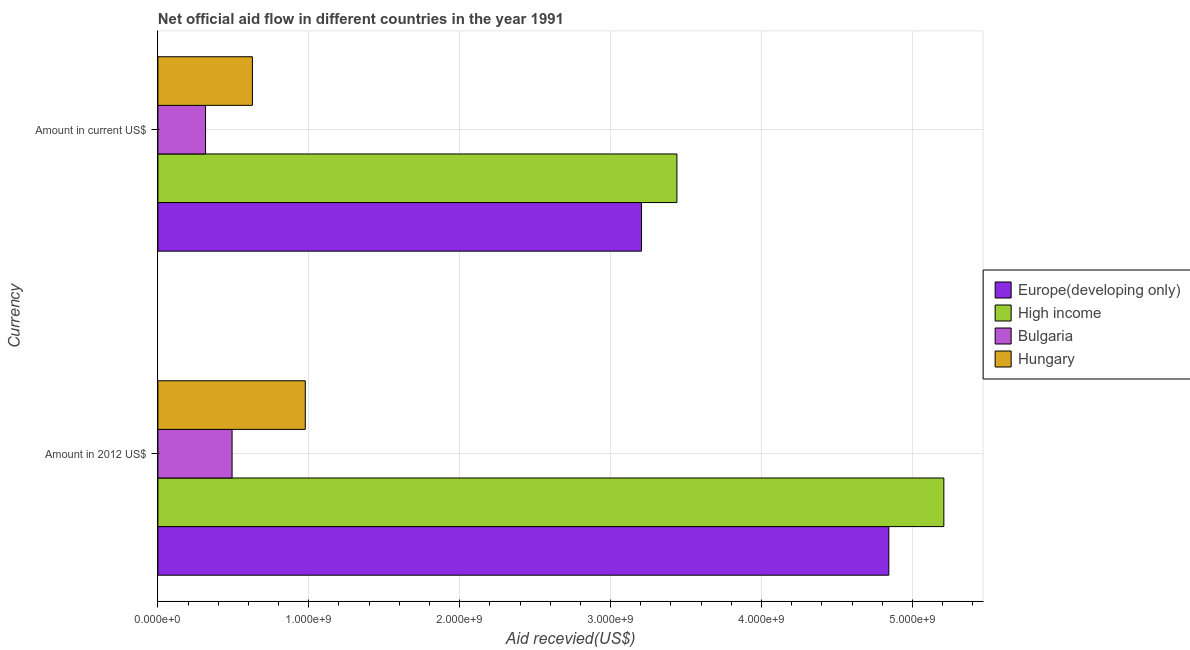Are the number of bars per tick equal to the number of legend labels?
Keep it short and to the point. Yes. Are the number of bars on each tick of the Y-axis equal?
Provide a short and direct response. Yes. How many bars are there on the 1st tick from the bottom?
Your response must be concise. 4. What is the label of the 1st group of bars from the top?
Make the answer very short. Amount in current US$. What is the amount of aid received(expressed in us$) in High income?
Give a very brief answer. 3.44e+09. Across all countries, what is the maximum amount of aid received(expressed in 2012 us$)?
Your response must be concise. 5.21e+09. Across all countries, what is the minimum amount of aid received(expressed in us$)?
Your answer should be very brief. 3.16e+08. In which country was the amount of aid received(expressed in us$) maximum?
Offer a terse response. High income. What is the total amount of aid received(expressed in us$) in the graph?
Provide a succinct answer. 7.59e+09. What is the difference between the amount of aid received(expressed in 2012 us$) in Bulgaria and that in High income?
Your answer should be very brief. -4.72e+09. What is the difference between the amount of aid received(expressed in us$) in Europe(developing only) and the amount of aid received(expressed in 2012 us$) in Bulgaria?
Make the answer very short. 2.71e+09. What is the average amount of aid received(expressed in us$) per country?
Make the answer very short. 1.90e+09. What is the difference between the amount of aid received(expressed in 2012 us$) and amount of aid received(expressed in us$) in Bulgaria?
Ensure brevity in your answer.  1.76e+08. In how many countries, is the amount of aid received(expressed in 2012 us$) greater than 2000000000 US$?
Your response must be concise. 2. What is the ratio of the amount of aid received(expressed in us$) in Hungary to that in Europe(developing only)?
Your answer should be compact. 0.2. Is the amount of aid received(expressed in 2012 us$) in Bulgaria less than that in Hungary?
Ensure brevity in your answer.  Yes. What does the 2nd bar from the top in Amount in 2012 US$ represents?
Ensure brevity in your answer.  Bulgaria. Are all the bars in the graph horizontal?
Provide a succinct answer. Yes. How are the legend labels stacked?
Provide a succinct answer. Vertical. What is the title of the graph?
Provide a short and direct response. Net official aid flow in different countries in the year 1991. What is the label or title of the X-axis?
Offer a terse response. Aid recevied(US$). What is the label or title of the Y-axis?
Your response must be concise. Currency. What is the Aid recevied(US$) in Europe(developing only) in Amount in 2012 US$?
Ensure brevity in your answer.  4.84e+09. What is the Aid recevied(US$) in High income in Amount in 2012 US$?
Your answer should be compact. 5.21e+09. What is the Aid recevied(US$) in Bulgaria in Amount in 2012 US$?
Give a very brief answer. 4.91e+08. What is the Aid recevied(US$) in Hungary in Amount in 2012 US$?
Your answer should be compact. 9.77e+08. What is the Aid recevied(US$) of Europe(developing only) in Amount in current US$?
Keep it short and to the point. 3.20e+09. What is the Aid recevied(US$) of High income in Amount in current US$?
Provide a succinct answer. 3.44e+09. What is the Aid recevied(US$) in Bulgaria in Amount in current US$?
Provide a short and direct response. 3.16e+08. What is the Aid recevied(US$) of Hungary in Amount in current US$?
Keep it short and to the point. 6.26e+08. Across all Currency, what is the maximum Aid recevied(US$) of Europe(developing only)?
Provide a short and direct response. 4.84e+09. Across all Currency, what is the maximum Aid recevied(US$) of High income?
Your answer should be very brief. 5.21e+09. Across all Currency, what is the maximum Aid recevied(US$) of Bulgaria?
Your answer should be compact. 4.91e+08. Across all Currency, what is the maximum Aid recevied(US$) of Hungary?
Offer a terse response. 9.77e+08. Across all Currency, what is the minimum Aid recevied(US$) in Europe(developing only)?
Offer a terse response. 3.20e+09. Across all Currency, what is the minimum Aid recevied(US$) of High income?
Your answer should be very brief. 3.44e+09. Across all Currency, what is the minimum Aid recevied(US$) of Bulgaria?
Ensure brevity in your answer.  3.16e+08. Across all Currency, what is the minimum Aid recevied(US$) in Hungary?
Your response must be concise. 6.26e+08. What is the total Aid recevied(US$) in Europe(developing only) in the graph?
Ensure brevity in your answer.  8.05e+09. What is the total Aid recevied(US$) of High income in the graph?
Ensure brevity in your answer.  8.65e+09. What is the total Aid recevied(US$) of Bulgaria in the graph?
Provide a succinct answer. 8.07e+08. What is the total Aid recevied(US$) in Hungary in the graph?
Give a very brief answer. 1.60e+09. What is the difference between the Aid recevied(US$) in Europe(developing only) in Amount in 2012 US$ and that in Amount in current US$?
Provide a succinct answer. 1.64e+09. What is the difference between the Aid recevied(US$) of High income in Amount in 2012 US$ and that in Amount in current US$?
Keep it short and to the point. 1.77e+09. What is the difference between the Aid recevied(US$) of Bulgaria in Amount in 2012 US$ and that in Amount in current US$?
Offer a terse response. 1.76e+08. What is the difference between the Aid recevied(US$) of Hungary in Amount in 2012 US$ and that in Amount in current US$?
Your answer should be compact. 3.50e+08. What is the difference between the Aid recevied(US$) of Europe(developing only) in Amount in 2012 US$ and the Aid recevied(US$) of High income in Amount in current US$?
Your answer should be compact. 1.40e+09. What is the difference between the Aid recevied(US$) in Europe(developing only) in Amount in 2012 US$ and the Aid recevied(US$) in Bulgaria in Amount in current US$?
Provide a succinct answer. 4.53e+09. What is the difference between the Aid recevied(US$) of Europe(developing only) in Amount in 2012 US$ and the Aid recevied(US$) of Hungary in Amount in current US$?
Offer a terse response. 4.22e+09. What is the difference between the Aid recevied(US$) in High income in Amount in 2012 US$ and the Aid recevied(US$) in Bulgaria in Amount in current US$?
Provide a succinct answer. 4.89e+09. What is the difference between the Aid recevied(US$) of High income in Amount in 2012 US$ and the Aid recevied(US$) of Hungary in Amount in current US$?
Your answer should be compact. 4.58e+09. What is the difference between the Aid recevied(US$) of Bulgaria in Amount in 2012 US$ and the Aid recevied(US$) of Hungary in Amount in current US$?
Offer a very short reply. -1.35e+08. What is the average Aid recevied(US$) in Europe(developing only) per Currency?
Your answer should be compact. 4.02e+09. What is the average Aid recevied(US$) in High income per Currency?
Offer a very short reply. 4.32e+09. What is the average Aid recevied(US$) in Bulgaria per Currency?
Your answer should be very brief. 4.04e+08. What is the average Aid recevied(US$) in Hungary per Currency?
Make the answer very short. 8.01e+08. What is the difference between the Aid recevied(US$) in Europe(developing only) and Aid recevied(US$) in High income in Amount in 2012 US$?
Your response must be concise. -3.64e+08. What is the difference between the Aid recevied(US$) in Europe(developing only) and Aid recevied(US$) in Bulgaria in Amount in 2012 US$?
Your answer should be very brief. 4.35e+09. What is the difference between the Aid recevied(US$) in Europe(developing only) and Aid recevied(US$) in Hungary in Amount in 2012 US$?
Ensure brevity in your answer.  3.87e+09. What is the difference between the Aid recevied(US$) of High income and Aid recevied(US$) of Bulgaria in Amount in 2012 US$?
Your response must be concise. 4.72e+09. What is the difference between the Aid recevied(US$) of High income and Aid recevied(US$) of Hungary in Amount in 2012 US$?
Your answer should be very brief. 4.23e+09. What is the difference between the Aid recevied(US$) of Bulgaria and Aid recevied(US$) of Hungary in Amount in 2012 US$?
Give a very brief answer. -4.85e+08. What is the difference between the Aid recevied(US$) in Europe(developing only) and Aid recevied(US$) in High income in Amount in current US$?
Provide a short and direct response. -2.35e+08. What is the difference between the Aid recevied(US$) of Europe(developing only) and Aid recevied(US$) of Bulgaria in Amount in current US$?
Provide a short and direct response. 2.89e+09. What is the difference between the Aid recevied(US$) of Europe(developing only) and Aid recevied(US$) of Hungary in Amount in current US$?
Give a very brief answer. 2.58e+09. What is the difference between the Aid recevied(US$) in High income and Aid recevied(US$) in Bulgaria in Amount in current US$?
Offer a very short reply. 3.12e+09. What is the difference between the Aid recevied(US$) of High income and Aid recevied(US$) of Hungary in Amount in current US$?
Offer a terse response. 2.81e+09. What is the difference between the Aid recevied(US$) in Bulgaria and Aid recevied(US$) in Hungary in Amount in current US$?
Offer a very short reply. -3.11e+08. What is the ratio of the Aid recevied(US$) in Europe(developing only) in Amount in 2012 US$ to that in Amount in current US$?
Provide a short and direct response. 1.51. What is the ratio of the Aid recevied(US$) of High income in Amount in 2012 US$ to that in Amount in current US$?
Your answer should be very brief. 1.51. What is the ratio of the Aid recevied(US$) of Bulgaria in Amount in 2012 US$ to that in Amount in current US$?
Your answer should be very brief. 1.56. What is the ratio of the Aid recevied(US$) in Hungary in Amount in 2012 US$ to that in Amount in current US$?
Ensure brevity in your answer.  1.56. What is the difference between the highest and the second highest Aid recevied(US$) in Europe(developing only)?
Provide a short and direct response. 1.64e+09. What is the difference between the highest and the second highest Aid recevied(US$) of High income?
Offer a terse response. 1.77e+09. What is the difference between the highest and the second highest Aid recevied(US$) in Bulgaria?
Keep it short and to the point. 1.76e+08. What is the difference between the highest and the second highest Aid recevied(US$) of Hungary?
Offer a very short reply. 3.50e+08. What is the difference between the highest and the lowest Aid recevied(US$) of Europe(developing only)?
Offer a terse response. 1.64e+09. What is the difference between the highest and the lowest Aid recevied(US$) in High income?
Ensure brevity in your answer.  1.77e+09. What is the difference between the highest and the lowest Aid recevied(US$) of Bulgaria?
Keep it short and to the point. 1.76e+08. What is the difference between the highest and the lowest Aid recevied(US$) in Hungary?
Keep it short and to the point. 3.50e+08. 